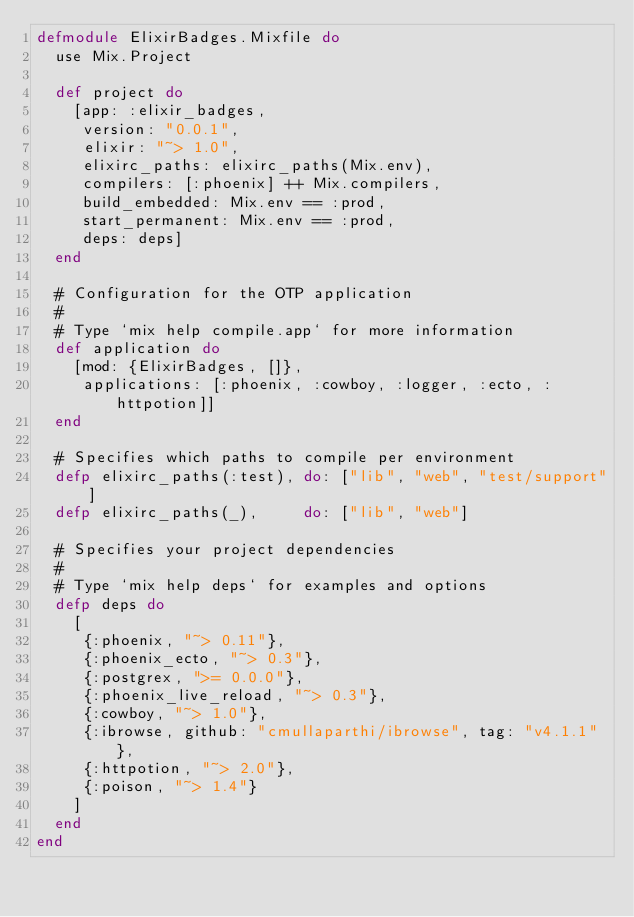<code> <loc_0><loc_0><loc_500><loc_500><_Elixir_>defmodule ElixirBadges.Mixfile do
  use Mix.Project

  def project do
    [app: :elixir_badges,
     version: "0.0.1",
     elixir: "~> 1.0",
     elixirc_paths: elixirc_paths(Mix.env),
     compilers: [:phoenix] ++ Mix.compilers,
     build_embedded: Mix.env == :prod,
     start_permanent: Mix.env == :prod,
     deps: deps]
  end

  # Configuration for the OTP application
  #
  # Type `mix help compile.app` for more information
  def application do
    [mod: {ElixirBadges, []},
     applications: [:phoenix, :cowboy, :logger, :ecto, :httpotion]]
  end

  # Specifies which paths to compile per environment
  defp elixirc_paths(:test), do: ["lib", "web", "test/support"]
  defp elixirc_paths(_),     do: ["lib", "web"]

  # Specifies your project dependencies
  #
  # Type `mix help deps` for examples and options
  defp deps do
    [
     {:phoenix, "~> 0.11"},
     {:phoenix_ecto, "~> 0.3"},
     {:postgrex, ">= 0.0.0"},
     {:phoenix_live_reload, "~> 0.3"},
     {:cowboy, "~> 1.0"},
     {:ibrowse, github: "cmullaparthi/ibrowse", tag: "v4.1.1"},
     {:httpotion, "~> 2.0"},
     {:poison, "~> 1.4"}
    ]
  end
end
</code> 